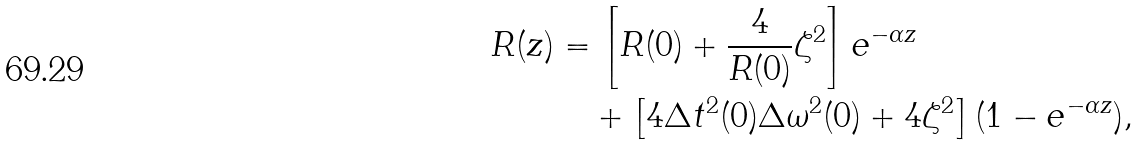<formula> <loc_0><loc_0><loc_500><loc_500>R ( z ) & = \left [ R ( 0 ) + \frac { 4 } { R ( 0 ) } \zeta ^ { 2 } \right ] e ^ { - \alpha z } \\ & \quad + \left [ 4 \Delta t ^ { 2 } ( 0 ) \Delta \omega ^ { 2 } ( 0 ) + 4 \zeta ^ { 2 } \right ] ( 1 - e ^ { - \alpha z } ) ,</formula> 